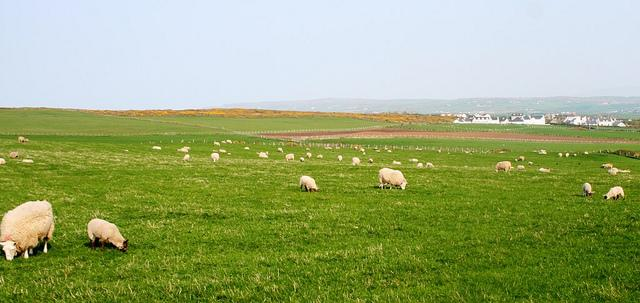What do these animals have?

Choices:
A) wings
B) long necks
C) wool
D) quills wool 